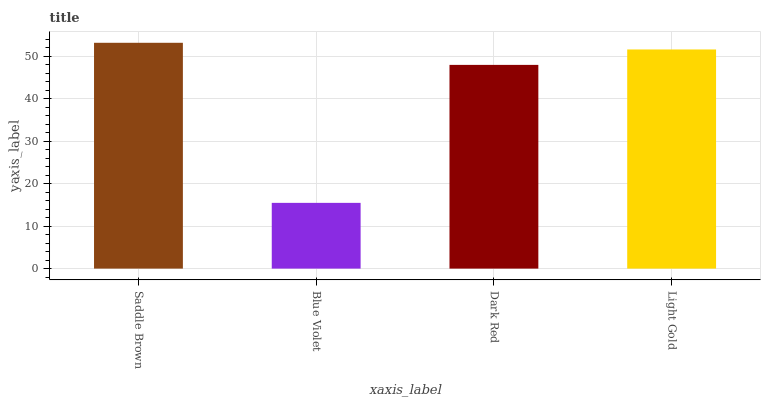Is Blue Violet the minimum?
Answer yes or no. Yes. Is Saddle Brown the maximum?
Answer yes or no. Yes. Is Dark Red the minimum?
Answer yes or no. No. Is Dark Red the maximum?
Answer yes or no. No. Is Dark Red greater than Blue Violet?
Answer yes or no. Yes. Is Blue Violet less than Dark Red?
Answer yes or no. Yes. Is Blue Violet greater than Dark Red?
Answer yes or no. No. Is Dark Red less than Blue Violet?
Answer yes or no. No. Is Light Gold the high median?
Answer yes or no. Yes. Is Dark Red the low median?
Answer yes or no. Yes. Is Dark Red the high median?
Answer yes or no. No. Is Light Gold the low median?
Answer yes or no. No. 